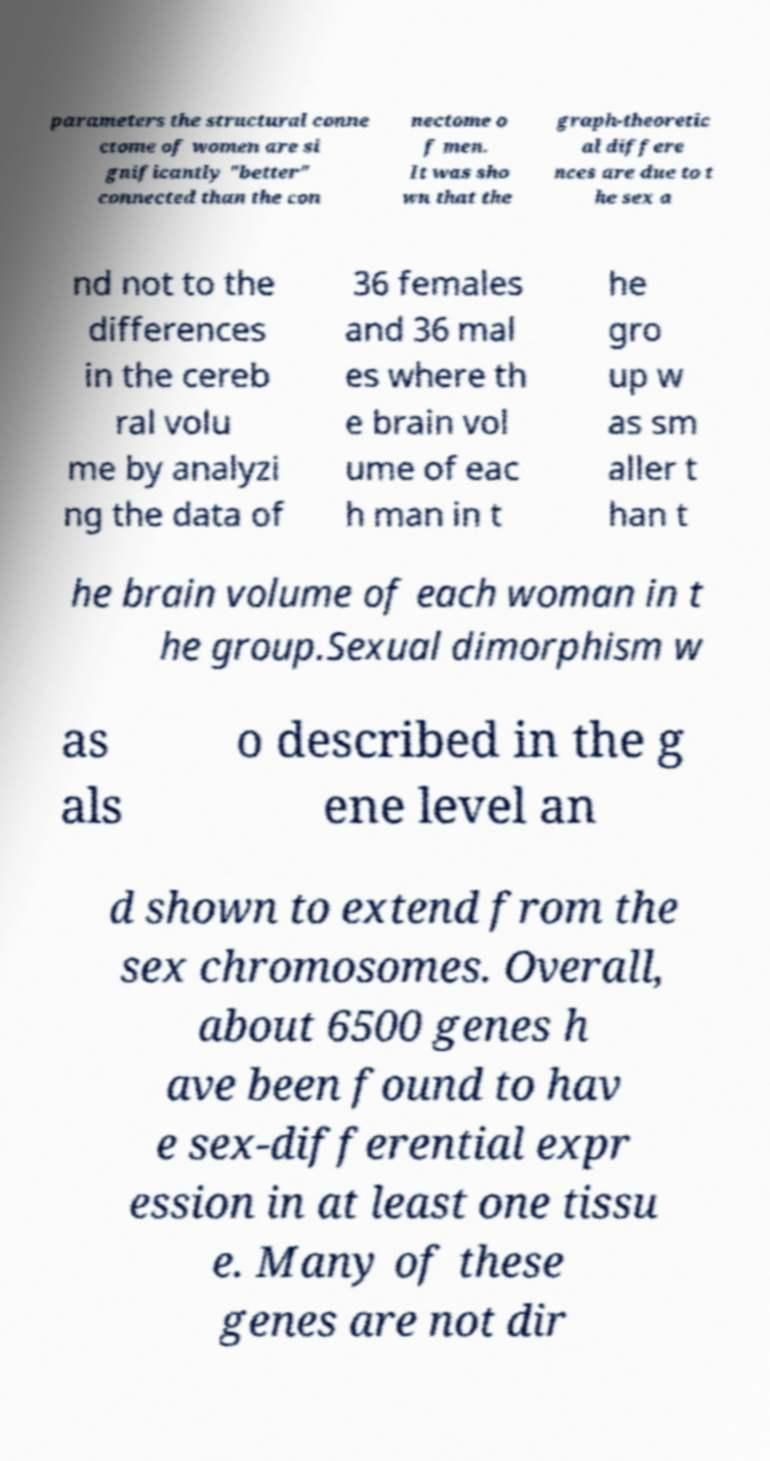Can you accurately transcribe the text from the provided image for me? parameters the structural conne ctome of women are si gnificantly "better" connected than the con nectome o f men. It was sho wn that the graph-theoretic al differe nces are due to t he sex a nd not to the differences in the cereb ral volu me by analyzi ng the data of 36 females and 36 mal es where th e brain vol ume of eac h man in t he gro up w as sm aller t han t he brain volume of each woman in t he group.Sexual dimorphism w as als o described in the g ene level an d shown to extend from the sex chromosomes. Overall, about 6500 genes h ave been found to hav e sex-differential expr ession in at least one tissu e. Many of these genes are not dir 